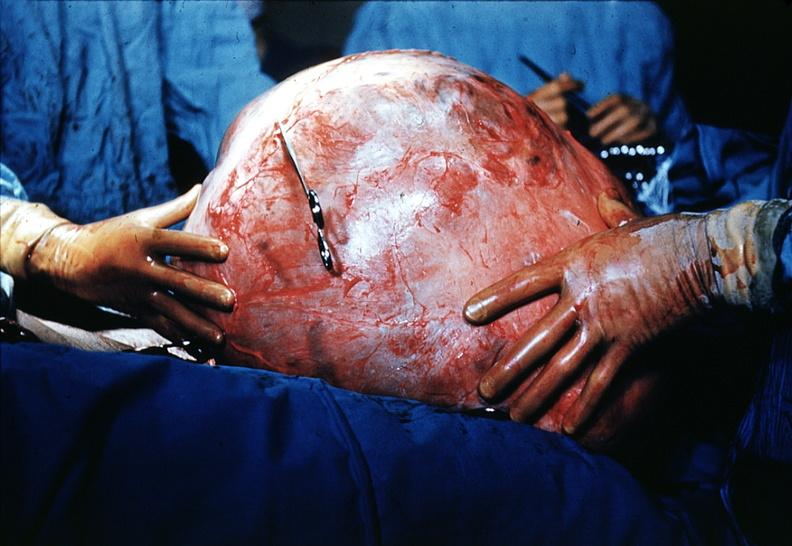s ovary present?
Answer the question using a single word or phrase. Yes 